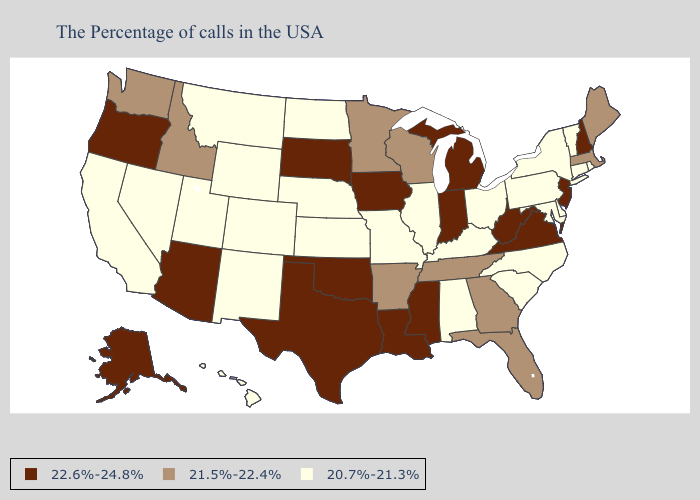Name the states that have a value in the range 20.7%-21.3%?
Concise answer only. Rhode Island, Vermont, Connecticut, New York, Delaware, Maryland, Pennsylvania, North Carolina, South Carolina, Ohio, Kentucky, Alabama, Illinois, Missouri, Kansas, Nebraska, North Dakota, Wyoming, Colorado, New Mexico, Utah, Montana, Nevada, California, Hawaii. What is the highest value in states that border Montana?
Be succinct. 22.6%-24.8%. Name the states that have a value in the range 20.7%-21.3%?
Keep it brief. Rhode Island, Vermont, Connecticut, New York, Delaware, Maryland, Pennsylvania, North Carolina, South Carolina, Ohio, Kentucky, Alabama, Illinois, Missouri, Kansas, Nebraska, North Dakota, Wyoming, Colorado, New Mexico, Utah, Montana, Nevada, California, Hawaii. Does the map have missing data?
Short answer required. No. What is the value of Delaware?
Concise answer only. 20.7%-21.3%. Which states have the highest value in the USA?
Give a very brief answer. New Hampshire, New Jersey, Virginia, West Virginia, Michigan, Indiana, Mississippi, Louisiana, Iowa, Oklahoma, Texas, South Dakota, Arizona, Oregon, Alaska. What is the value of Missouri?
Concise answer only. 20.7%-21.3%. Does Utah have a lower value than Connecticut?
Give a very brief answer. No. Which states have the highest value in the USA?
Keep it brief. New Hampshire, New Jersey, Virginia, West Virginia, Michigan, Indiana, Mississippi, Louisiana, Iowa, Oklahoma, Texas, South Dakota, Arizona, Oregon, Alaska. Name the states that have a value in the range 22.6%-24.8%?
Give a very brief answer. New Hampshire, New Jersey, Virginia, West Virginia, Michigan, Indiana, Mississippi, Louisiana, Iowa, Oklahoma, Texas, South Dakota, Arizona, Oregon, Alaska. Name the states that have a value in the range 22.6%-24.8%?
Quick response, please. New Hampshire, New Jersey, Virginia, West Virginia, Michigan, Indiana, Mississippi, Louisiana, Iowa, Oklahoma, Texas, South Dakota, Arizona, Oregon, Alaska. Is the legend a continuous bar?
Give a very brief answer. No. What is the value of Texas?
Short answer required. 22.6%-24.8%. Does Kansas have the lowest value in the USA?
Concise answer only. Yes. Does Wyoming have a lower value than Missouri?
Quick response, please. No. 